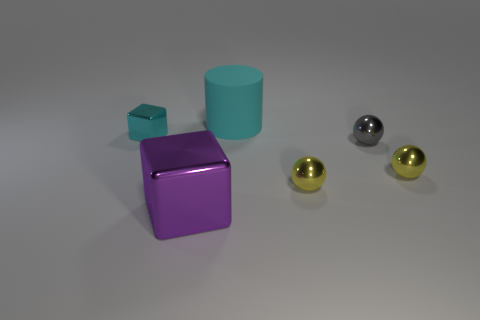Subtract all green balls. Subtract all red cylinders. How many balls are left? 3 Add 3 purple metallic objects. How many objects exist? 9 Subtract all blocks. How many objects are left? 4 Add 1 big matte things. How many big matte things are left? 2 Add 4 cyan metallic cubes. How many cyan metallic cubes exist? 5 Subtract 0 brown cylinders. How many objects are left? 6 Subtract all tiny gray spheres. Subtract all tiny cyan shiny objects. How many objects are left? 4 